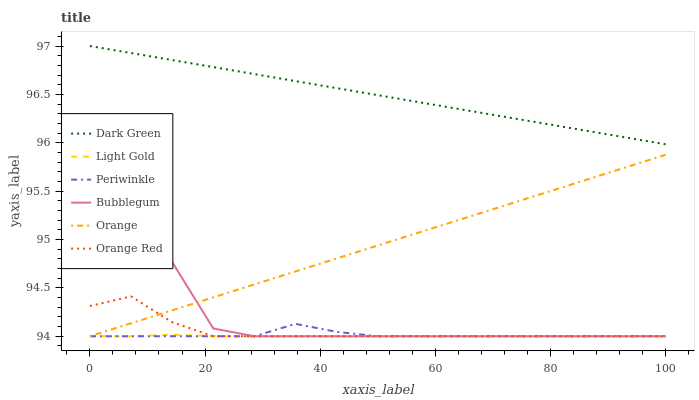Does Light Gold have the minimum area under the curve?
Answer yes or no. Yes. Does Dark Green have the maximum area under the curve?
Answer yes or no. Yes. Does Periwinkle have the minimum area under the curve?
Answer yes or no. No. Does Periwinkle have the maximum area under the curve?
Answer yes or no. No. Is Dark Green the smoothest?
Answer yes or no. Yes. Is Bubblegum the roughest?
Answer yes or no. Yes. Is Periwinkle the smoothest?
Answer yes or no. No. Is Periwinkle the roughest?
Answer yes or no. No. Does Bubblegum have the lowest value?
Answer yes or no. Yes. Does Dark Green have the lowest value?
Answer yes or no. No. Does Dark Green have the highest value?
Answer yes or no. Yes. Does Periwinkle have the highest value?
Answer yes or no. No. Is Bubblegum less than Dark Green?
Answer yes or no. Yes. Is Dark Green greater than Orange Red?
Answer yes or no. Yes. Does Orange Red intersect Periwinkle?
Answer yes or no. Yes. Is Orange Red less than Periwinkle?
Answer yes or no. No. Is Orange Red greater than Periwinkle?
Answer yes or no. No. Does Bubblegum intersect Dark Green?
Answer yes or no. No. 